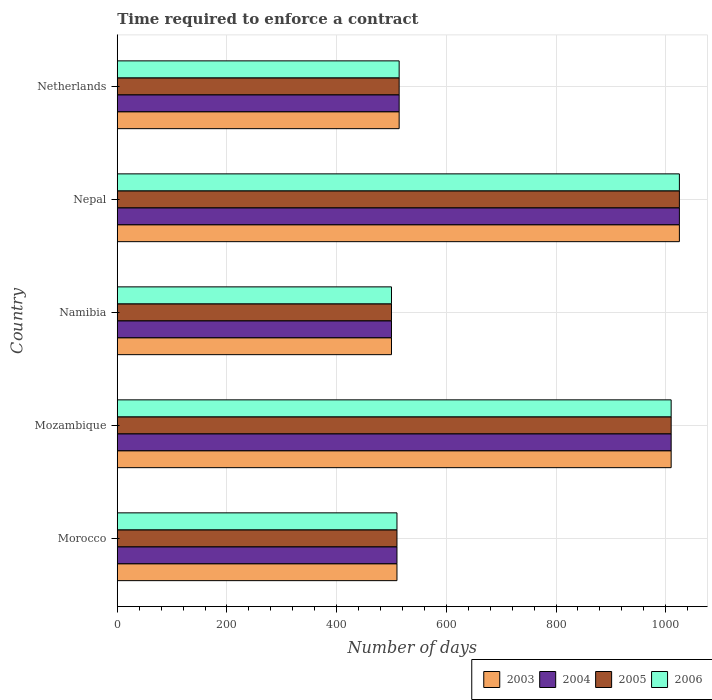How many groups of bars are there?
Provide a short and direct response. 5. How many bars are there on the 4th tick from the top?
Make the answer very short. 4. How many bars are there on the 4th tick from the bottom?
Make the answer very short. 4. What is the label of the 1st group of bars from the top?
Keep it short and to the point. Netherlands. What is the number of days required to enforce a contract in 2004 in Nepal?
Keep it short and to the point. 1025. Across all countries, what is the maximum number of days required to enforce a contract in 2004?
Ensure brevity in your answer.  1025. In which country was the number of days required to enforce a contract in 2004 maximum?
Your response must be concise. Nepal. In which country was the number of days required to enforce a contract in 2006 minimum?
Keep it short and to the point. Namibia. What is the total number of days required to enforce a contract in 2003 in the graph?
Your answer should be compact. 3559. What is the difference between the number of days required to enforce a contract in 2003 in Namibia and that in Nepal?
Your answer should be very brief. -525. What is the difference between the number of days required to enforce a contract in 2005 in Netherlands and the number of days required to enforce a contract in 2003 in Nepal?
Keep it short and to the point. -511. What is the average number of days required to enforce a contract in 2004 per country?
Offer a terse response. 711.8. What is the difference between the number of days required to enforce a contract in 2006 and number of days required to enforce a contract in 2004 in Morocco?
Make the answer very short. 0. In how many countries, is the number of days required to enforce a contract in 2003 greater than 880 days?
Keep it short and to the point. 2. What is the ratio of the number of days required to enforce a contract in 2003 in Namibia to that in Netherlands?
Your response must be concise. 0.97. Is the difference between the number of days required to enforce a contract in 2006 in Morocco and Mozambique greater than the difference between the number of days required to enforce a contract in 2004 in Morocco and Mozambique?
Your response must be concise. No. What is the difference between the highest and the second highest number of days required to enforce a contract in 2004?
Give a very brief answer. 15. What is the difference between the highest and the lowest number of days required to enforce a contract in 2006?
Make the answer very short. 525. Is it the case that in every country, the sum of the number of days required to enforce a contract in 2004 and number of days required to enforce a contract in 2006 is greater than the sum of number of days required to enforce a contract in 2003 and number of days required to enforce a contract in 2005?
Provide a succinct answer. No. What does the 2nd bar from the top in Nepal represents?
Your answer should be very brief. 2005. Is it the case that in every country, the sum of the number of days required to enforce a contract in 2004 and number of days required to enforce a contract in 2003 is greater than the number of days required to enforce a contract in 2006?
Keep it short and to the point. Yes. What is the difference between two consecutive major ticks on the X-axis?
Provide a short and direct response. 200. Are the values on the major ticks of X-axis written in scientific E-notation?
Give a very brief answer. No. Does the graph contain grids?
Your answer should be very brief. Yes. Where does the legend appear in the graph?
Make the answer very short. Bottom right. How are the legend labels stacked?
Ensure brevity in your answer.  Horizontal. What is the title of the graph?
Ensure brevity in your answer.  Time required to enforce a contract. Does "2006" appear as one of the legend labels in the graph?
Make the answer very short. Yes. What is the label or title of the X-axis?
Keep it short and to the point. Number of days. What is the label or title of the Y-axis?
Your answer should be very brief. Country. What is the Number of days of 2003 in Morocco?
Offer a terse response. 510. What is the Number of days in 2004 in Morocco?
Provide a short and direct response. 510. What is the Number of days of 2005 in Morocco?
Keep it short and to the point. 510. What is the Number of days of 2006 in Morocco?
Give a very brief answer. 510. What is the Number of days of 2003 in Mozambique?
Provide a succinct answer. 1010. What is the Number of days of 2004 in Mozambique?
Your answer should be compact. 1010. What is the Number of days of 2005 in Mozambique?
Provide a succinct answer. 1010. What is the Number of days of 2006 in Mozambique?
Provide a short and direct response. 1010. What is the Number of days of 2004 in Namibia?
Ensure brevity in your answer.  500. What is the Number of days in 2005 in Namibia?
Keep it short and to the point. 500. What is the Number of days of 2003 in Nepal?
Provide a succinct answer. 1025. What is the Number of days in 2004 in Nepal?
Offer a terse response. 1025. What is the Number of days of 2005 in Nepal?
Your answer should be compact. 1025. What is the Number of days of 2006 in Nepal?
Offer a terse response. 1025. What is the Number of days in 2003 in Netherlands?
Your response must be concise. 514. What is the Number of days in 2004 in Netherlands?
Give a very brief answer. 514. What is the Number of days of 2005 in Netherlands?
Provide a short and direct response. 514. What is the Number of days of 2006 in Netherlands?
Your answer should be compact. 514. Across all countries, what is the maximum Number of days of 2003?
Offer a terse response. 1025. Across all countries, what is the maximum Number of days of 2004?
Keep it short and to the point. 1025. Across all countries, what is the maximum Number of days in 2005?
Offer a very short reply. 1025. Across all countries, what is the maximum Number of days of 2006?
Make the answer very short. 1025. Across all countries, what is the minimum Number of days in 2003?
Provide a short and direct response. 500. Across all countries, what is the minimum Number of days of 2005?
Offer a very short reply. 500. What is the total Number of days in 2003 in the graph?
Make the answer very short. 3559. What is the total Number of days of 2004 in the graph?
Your answer should be very brief. 3559. What is the total Number of days in 2005 in the graph?
Give a very brief answer. 3559. What is the total Number of days of 2006 in the graph?
Offer a terse response. 3559. What is the difference between the Number of days of 2003 in Morocco and that in Mozambique?
Offer a very short reply. -500. What is the difference between the Number of days of 2004 in Morocco and that in Mozambique?
Offer a very short reply. -500. What is the difference between the Number of days in 2005 in Morocco and that in Mozambique?
Ensure brevity in your answer.  -500. What is the difference between the Number of days of 2006 in Morocco and that in Mozambique?
Ensure brevity in your answer.  -500. What is the difference between the Number of days in 2003 in Morocco and that in Namibia?
Offer a terse response. 10. What is the difference between the Number of days of 2006 in Morocco and that in Namibia?
Give a very brief answer. 10. What is the difference between the Number of days of 2003 in Morocco and that in Nepal?
Keep it short and to the point. -515. What is the difference between the Number of days in 2004 in Morocco and that in Nepal?
Provide a short and direct response. -515. What is the difference between the Number of days of 2005 in Morocco and that in Nepal?
Offer a terse response. -515. What is the difference between the Number of days of 2006 in Morocco and that in Nepal?
Make the answer very short. -515. What is the difference between the Number of days of 2004 in Morocco and that in Netherlands?
Your response must be concise. -4. What is the difference between the Number of days of 2003 in Mozambique and that in Namibia?
Make the answer very short. 510. What is the difference between the Number of days of 2004 in Mozambique and that in Namibia?
Your response must be concise. 510. What is the difference between the Number of days in 2005 in Mozambique and that in Namibia?
Offer a terse response. 510. What is the difference between the Number of days of 2006 in Mozambique and that in Namibia?
Provide a short and direct response. 510. What is the difference between the Number of days in 2003 in Mozambique and that in Nepal?
Your answer should be very brief. -15. What is the difference between the Number of days of 2004 in Mozambique and that in Nepal?
Make the answer very short. -15. What is the difference between the Number of days in 2005 in Mozambique and that in Nepal?
Provide a short and direct response. -15. What is the difference between the Number of days of 2006 in Mozambique and that in Nepal?
Keep it short and to the point. -15. What is the difference between the Number of days of 2003 in Mozambique and that in Netherlands?
Your answer should be very brief. 496. What is the difference between the Number of days in 2004 in Mozambique and that in Netherlands?
Your answer should be very brief. 496. What is the difference between the Number of days in 2005 in Mozambique and that in Netherlands?
Give a very brief answer. 496. What is the difference between the Number of days of 2006 in Mozambique and that in Netherlands?
Make the answer very short. 496. What is the difference between the Number of days of 2003 in Namibia and that in Nepal?
Give a very brief answer. -525. What is the difference between the Number of days of 2004 in Namibia and that in Nepal?
Your answer should be very brief. -525. What is the difference between the Number of days of 2005 in Namibia and that in Nepal?
Make the answer very short. -525. What is the difference between the Number of days of 2006 in Namibia and that in Nepal?
Your answer should be compact. -525. What is the difference between the Number of days in 2004 in Namibia and that in Netherlands?
Your response must be concise. -14. What is the difference between the Number of days of 2006 in Namibia and that in Netherlands?
Your response must be concise. -14. What is the difference between the Number of days of 2003 in Nepal and that in Netherlands?
Make the answer very short. 511. What is the difference between the Number of days of 2004 in Nepal and that in Netherlands?
Provide a short and direct response. 511. What is the difference between the Number of days in 2005 in Nepal and that in Netherlands?
Give a very brief answer. 511. What is the difference between the Number of days of 2006 in Nepal and that in Netherlands?
Provide a succinct answer. 511. What is the difference between the Number of days of 2003 in Morocco and the Number of days of 2004 in Mozambique?
Keep it short and to the point. -500. What is the difference between the Number of days of 2003 in Morocco and the Number of days of 2005 in Mozambique?
Keep it short and to the point. -500. What is the difference between the Number of days of 2003 in Morocco and the Number of days of 2006 in Mozambique?
Provide a succinct answer. -500. What is the difference between the Number of days in 2004 in Morocco and the Number of days in 2005 in Mozambique?
Make the answer very short. -500. What is the difference between the Number of days in 2004 in Morocco and the Number of days in 2006 in Mozambique?
Offer a terse response. -500. What is the difference between the Number of days of 2005 in Morocco and the Number of days of 2006 in Mozambique?
Offer a very short reply. -500. What is the difference between the Number of days in 2003 in Morocco and the Number of days in 2006 in Namibia?
Ensure brevity in your answer.  10. What is the difference between the Number of days of 2003 in Morocco and the Number of days of 2004 in Nepal?
Offer a very short reply. -515. What is the difference between the Number of days of 2003 in Morocco and the Number of days of 2005 in Nepal?
Your answer should be compact. -515. What is the difference between the Number of days of 2003 in Morocco and the Number of days of 2006 in Nepal?
Ensure brevity in your answer.  -515. What is the difference between the Number of days of 2004 in Morocco and the Number of days of 2005 in Nepal?
Your answer should be compact. -515. What is the difference between the Number of days in 2004 in Morocco and the Number of days in 2006 in Nepal?
Make the answer very short. -515. What is the difference between the Number of days of 2005 in Morocco and the Number of days of 2006 in Nepal?
Provide a succinct answer. -515. What is the difference between the Number of days in 2003 in Morocco and the Number of days in 2005 in Netherlands?
Make the answer very short. -4. What is the difference between the Number of days of 2003 in Morocco and the Number of days of 2006 in Netherlands?
Make the answer very short. -4. What is the difference between the Number of days of 2004 in Morocco and the Number of days of 2006 in Netherlands?
Ensure brevity in your answer.  -4. What is the difference between the Number of days of 2005 in Morocco and the Number of days of 2006 in Netherlands?
Make the answer very short. -4. What is the difference between the Number of days of 2003 in Mozambique and the Number of days of 2004 in Namibia?
Your response must be concise. 510. What is the difference between the Number of days of 2003 in Mozambique and the Number of days of 2005 in Namibia?
Provide a succinct answer. 510. What is the difference between the Number of days in 2003 in Mozambique and the Number of days in 2006 in Namibia?
Offer a terse response. 510. What is the difference between the Number of days of 2004 in Mozambique and the Number of days of 2005 in Namibia?
Your answer should be compact. 510. What is the difference between the Number of days of 2004 in Mozambique and the Number of days of 2006 in Namibia?
Provide a short and direct response. 510. What is the difference between the Number of days in 2005 in Mozambique and the Number of days in 2006 in Namibia?
Your answer should be compact. 510. What is the difference between the Number of days in 2003 in Mozambique and the Number of days in 2004 in Nepal?
Ensure brevity in your answer.  -15. What is the difference between the Number of days of 2003 in Mozambique and the Number of days of 2005 in Nepal?
Offer a very short reply. -15. What is the difference between the Number of days of 2003 in Mozambique and the Number of days of 2006 in Nepal?
Provide a succinct answer. -15. What is the difference between the Number of days in 2004 in Mozambique and the Number of days in 2005 in Nepal?
Your answer should be compact. -15. What is the difference between the Number of days of 2004 in Mozambique and the Number of days of 2006 in Nepal?
Your answer should be compact. -15. What is the difference between the Number of days of 2003 in Mozambique and the Number of days of 2004 in Netherlands?
Keep it short and to the point. 496. What is the difference between the Number of days in 2003 in Mozambique and the Number of days in 2005 in Netherlands?
Offer a very short reply. 496. What is the difference between the Number of days of 2003 in Mozambique and the Number of days of 2006 in Netherlands?
Your answer should be very brief. 496. What is the difference between the Number of days in 2004 in Mozambique and the Number of days in 2005 in Netherlands?
Make the answer very short. 496. What is the difference between the Number of days of 2004 in Mozambique and the Number of days of 2006 in Netherlands?
Offer a very short reply. 496. What is the difference between the Number of days in 2005 in Mozambique and the Number of days in 2006 in Netherlands?
Provide a succinct answer. 496. What is the difference between the Number of days of 2003 in Namibia and the Number of days of 2004 in Nepal?
Give a very brief answer. -525. What is the difference between the Number of days of 2003 in Namibia and the Number of days of 2005 in Nepal?
Offer a very short reply. -525. What is the difference between the Number of days of 2003 in Namibia and the Number of days of 2006 in Nepal?
Give a very brief answer. -525. What is the difference between the Number of days of 2004 in Namibia and the Number of days of 2005 in Nepal?
Ensure brevity in your answer.  -525. What is the difference between the Number of days of 2004 in Namibia and the Number of days of 2006 in Nepal?
Make the answer very short. -525. What is the difference between the Number of days in 2005 in Namibia and the Number of days in 2006 in Nepal?
Your answer should be compact. -525. What is the difference between the Number of days in 2003 in Namibia and the Number of days in 2006 in Netherlands?
Your answer should be very brief. -14. What is the difference between the Number of days of 2004 in Namibia and the Number of days of 2005 in Netherlands?
Your answer should be compact. -14. What is the difference between the Number of days in 2004 in Namibia and the Number of days in 2006 in Netherlands?
Provide a succinct answer. -14. What is the difference between the Number of days of 2003 in Nepal and the Number of days of 2004 in Netherlands?
Offer a very short reply. 511. What is the difference between the Number of days in 2003 in Nepal and the Number of days in 2005 in Netherlands?
Keep it short and to the point. 511. What is the difference between the Number of days in 2003 in Nepal and the Number of days in 2006 in Netherlands?
Offer a terse response. 511. What is the difference between the Number of days in 2004 in Nepal and the Number of days in 2005 in Netherlands?
Provide a short and direct response. 511. What is the difference between the Number of days of 2004 in Nepal and the Number of days of 2006 in Netherlands?
Your response must be concise. 511. What is the difference between the Number of days in 2005 in Nepal and the Number of days in 2006 in Netherlands?
Your answer should be very brief. 511. What is the average Number of days in 2003 per country?
Provide a short and direct response. 711.8. What is the average Number of days in 2004 per country?
Your answer should be very brief. 711.8. What is the average Number of days in 2005 per country?
Give a very brief answer. 711.8. What is the average Number of days of 2006 per country?
Make the answer very short. 711.8. What is the difference between the Number of days of 2003 and Number of days of 2004 in Morocco?
Offer a very short reply. 0. What is the difference between the Number of days in 2003 and Number of days in 2005 in Morocco?
Your answer should be very brief. 0. What is the difference between the Number of days in 2003 and Number of days in 2006 in Morocco?
Your answer should be compact. 0. What is the difference between the Number of days of 2005 and Number of days of 2006 in Morocco?
Make the answer very short. 0. What is the difference between the Number of days in 2003 and Number of days in 2005 in Mozambique?
Offer a terse response. 0. What is the difference between the Number of days of 2003 and Number of days of 2006 in Mozambique?
Give a very brief answer. 0. What is the difference between the Number of days of 2004 and Number of days of 2005 in Mozambique?
Your answer should be compact. 0. What is the difference between the Number of days in 2005 and Number of days in 2006 in Mozambique?
Give a very brief answer. 0. What is the difference between the Number of days of 2003 and Number of days of 2004 in Namibia?
Provide a succinct answer. 0. What is the difference between the Number of days in 2003 and Number of days in 2005 in Namibia?
Offer a terse response. 0. What is the difference between the Number of days in 2004 and Number of days in 2005 in Namibia?
Give a very brief answer. 0. What is the difference between the Number of days in 2004 and Number of days in 2006 in Namibia?
Keep it short and to the point. 0. What is the difference between the Number of days of 2005 and Number of days of 2006 in Namibia?
Keep it short and to the point. 0. What is the difference between the Number of days in 2003 and Number of days in 2004 in Nepal?
Your response must be concise. 0. What is the difference between the Number of days of 2003 and Number of days of 2006 in Nepal?
Give a very brief answer. 0. What is the difference between the Number of days of 2004 and Number of days of 2005 in Nepal?
Your response must be concise. 0. What is the difference between the Number of days in 2004 and Number of days in 2006 in Nepal?
Give a very brief answer. 0. What is the difference between the Number of days of 2005 and Number of days of 2006 in Nepal?
Ensure brevity in your answer.  0. What is the difference between the Number of days of 2004 and Number of days of 2006 in Netherlands?
Offer a very short reply. 0. What is the ratio of the Number of days in 2003 in Morocco to that in Mozambique?
Your answer should be very brief. 0.51. What is the ratio of the Number of days of 2004 in Morocco to that in Mozambique?
Give a very brief answer. 0.51. What is the ratio of the Number of days in 2005 in Morocco to that in Mozambique?
Your answer should be compact. 0.51. What is the ratio of the Number of days in 2006 in Morocco to that in Mozambique?
Provide a short and direct response. 0.51. What is the ratio of the Number of days in 2004 in Morocco to that in Namibia?
Make the answer very short. 1.02. What is the ratio of the Number of days in 2005 in Morocco to that in Namibia?
Your response must be concise. 1.02. What is the ratio of the Number of days of 2006 in Morocco to that in Namibia?
Ensure brevity in your answer.  1.02. What is the ratio of the Number of days of 2003 in Morocco to that in Nepal?
Your answer should be very brief. 0.5. What is the ratio of the Number of days in 2004 in Morocco to that in Nepal?
Keep it short and to the point. 0.5. What is the ratio of the Number of days of 2005 in Morocco to that in Nepal?
Provide a succinct answer. 0.5. What is the ratio of the Number of days of 2006 in Morocco to that in Nepal?
Give a very brief answer. 0.5. What is the ratio of the Number of days in 2004 in Morocco to that in Netherlands?
Give a very brief answer. 0.99. What is the ratio of the Number of days of 2006 in Morocco to that in Netherlands?
Ensure brevity in your answer.  0.99. What is the ratio of the Number of days of 2003 in Mozambique to that in Namibia?
Offer a very short reply. 2.02. What is the ratio of the Number of days in 2004 in Mozambique to that in Namibia?
Provide a succinct answer. 2.02. What is the ratio of the Number of days of 2005 in Mozambique to that in Namibia?
Provide a succinct answer. 2.02. What is the ratio of the Number of days in 2006 in Mozambique to that in Namibia?
Offer a terse response. 2.02. What is the ratio of the Number of days in 2003 in Mozambique to that in Nepal?
Provide a succinct answer. 0.99. What is the ratio of the Number of days of 2004 in Mozambique to that in Nepal?
Give a very brief answer. 0.99. What is the ratio of the Number of days of 2005 in Mozambique to that in Nepal?
Make the answer very short. 0.99. What is the ratio of the Number of days in 2006 in Mozambique to that in Nepal?
Offer a terse response. 0.99. What is the ratio of the Number of days of 2003 in Mozambique to that in Netherlands?
Keep it short and to the point. 1.97. What is the ratio of the Number of days of 2004 in Mozambique to that in Netherlands?
Offer a terse response. 1.97. What is the ratio of the Number of days in 2005 in Mozambique to that in Netherlands?
Offer a terse response. 1.97. What is the ratio of the Number of days in 2006 in Mozambique to that in Netherlands?
Provide a succinct answer. 1.97. What is the ratio of the Number of days in 2003 in Namibia to that in Nepal?
Your answer should be compact. 0.49. What is the ratio of the Number of days in 2004 in Namibia to that in Nepal?
Your response must be concise. 0.49. What is the ratio of the Number of days of 2005 in Namibia to that in Nepal?
Offer a very short reply. 0.49. What is the ratio of the Number of days of 2006 in Namibia to that in Nepal?
Offer a very short reply. 0.49. What is the ratio of the Number of days of 2003 in Namibia to that in Netherlands?
Provide a short and direct response. 0.97. What is the ratio of the Number of days in 2004 in Namibia to that in Netherlands?
Make the answer very short. 0.97. What is the ratio of the Number of days in 2005 in Namibia to that in Netherlands?
Your answer should be compact. 0.97. What is the ratio of the Number of days of 2006 in Namibia to that in Netherlands?
Your response must be concise. 0.97. What is the ratio of the Number of days of 2003 in Nepal to that in Netherlands?
Provide a short and direct response. 1.99. What is the ratio of the Number of days of 2004 in Nepal to that in Netherlands?
Give a very brief answer. 1.99. What is the ratio of the Number of days of 2005 in Nepal to that in Netherlands?
Make the answer very short. 1.99. What is the ratio of the Number of days of 2006 in Nepal to that in Netherlands?
Provide a short and direct response. 1.99. What is the difference between the highest and the second highest Number of days in 2003?
Keep it short and to the point. 15. What is the difference between the highest and the second highest Number of days in 2004?
Give a very brief answer. 15. What is the difference between the highest and the second highest Number of days of 2005?
Provide a succinct answer. 15. What is the difference between the highest and the lowest Number of days of 2003?
Offer a terse response. 525. What is the difference between the highest and the lowest Number of days of 2004?
Ensure brevity in your answer.  525. What is the difference between the highest and the lowest Number of days in 2005?
Give a very brief answer. 525. What is the difference between the highest and the lowest Number of days of 2006?
Provide a short and direct response. 525. 